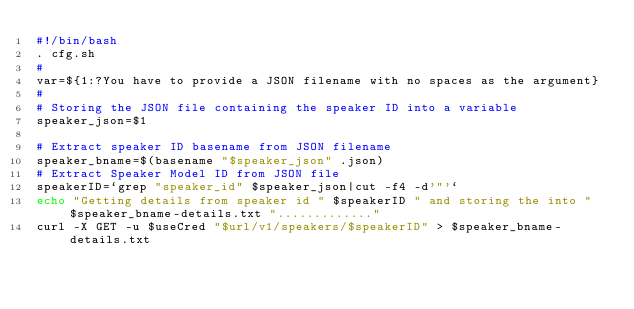Convert code to text. <code><loc_0><loc_0><loc_500><loc_500><_Bash_>#!/bin/bash
. cfg.sh
#
var=${1:?You have to provide a JSON filename with no spaces as the argument}
#
# Storing the JSON file containing the speaker ID into a variable
speaker_json=$1

# Extract speaker ID basename from JSON filename
speaker_bname=$(basename "$speaker_json" .json)
# Extract Speaker Model ID from JSON file
speakerID=`grep "speaker_id" $speaker_json|cut -f4 -d'"'`
echo "Getting details from speaker id " $speakerID " and storing the into " $speaker_bname-details.txt "............."
curl -X GET -u $useCred "$url/v1/speakers/$speakerID" > $speaker_bname-details.txt
</code> 